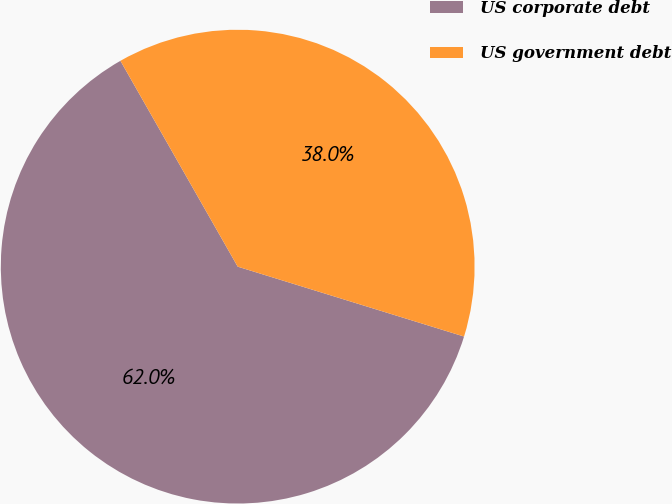Convert chart to OTSL. <chart><loc_0><loc_0><loc_500><loc_500><pie_chart><fcel>US corporate debt<fcel>US government debt<nl><fcel>61.99%<fcel>38.01%<nl></chart> 